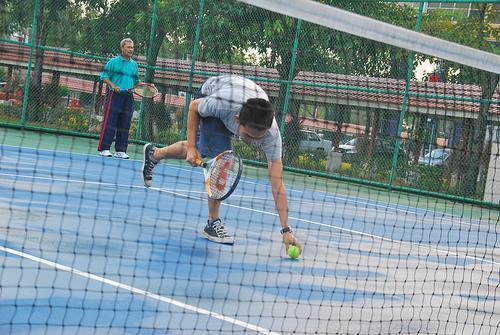How many people are in the picture?
Give a very brief answer. 2. 